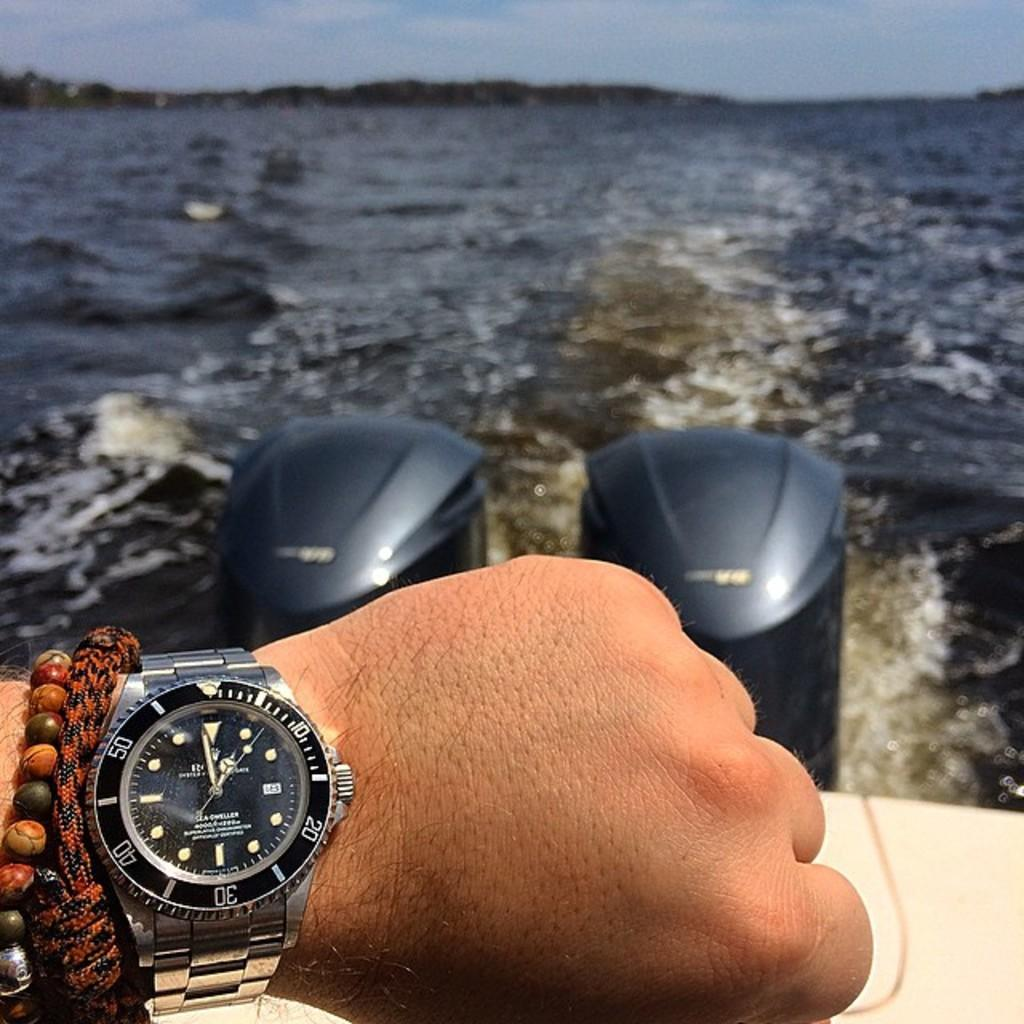Provide a one-sentence caption for the provided image. Someone is on a boat wearing bracelets and a rolex watch. 